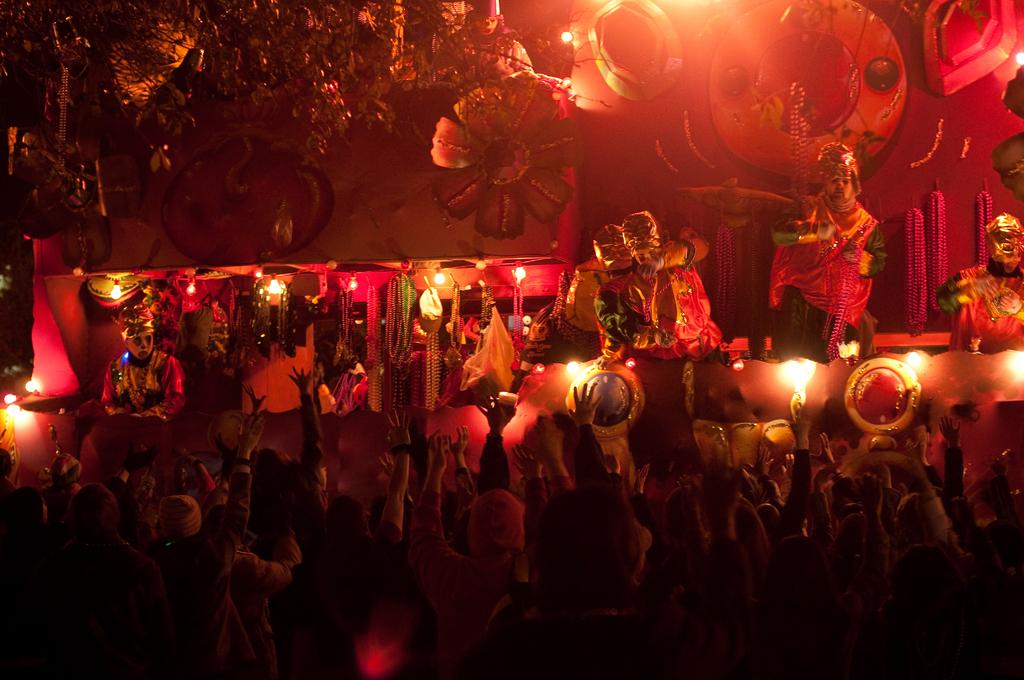How many people are in the image? There is a group of people standing in the image. What else can be seen in the image besides the people? There are sculptures and lights visible in the image. How many oranges are being used to create the brake pattern on the pig in the image? There are no oranges, brake patterns, or pigs present in the image. 